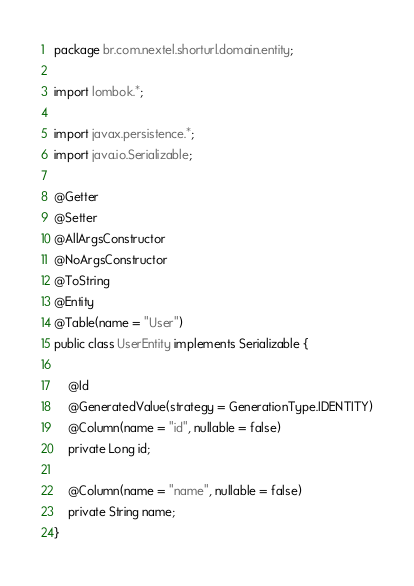Convert code to text. <code><loc_0><loc_0><loc_500><loc_500><_Java_>package br.com.nextel.shorturl.domain.entity;

import lombok.*;

import javax.persistence.*;
import java.io.Serializable;

@Getter
@Setter
@AllArgsConstructor
@NoArgsConstructor
@ToString
@Entity
@Table(name = "User")
public class UserEntity implements Serializable {

	@Id
	@GeneratedValue(strategy = GenerationType.IDENTITY)
	@Column(name = "id", nullable = false)
	private Long id;

	@Column(name = "name", nullable = false)
	private String name;
}</code> 